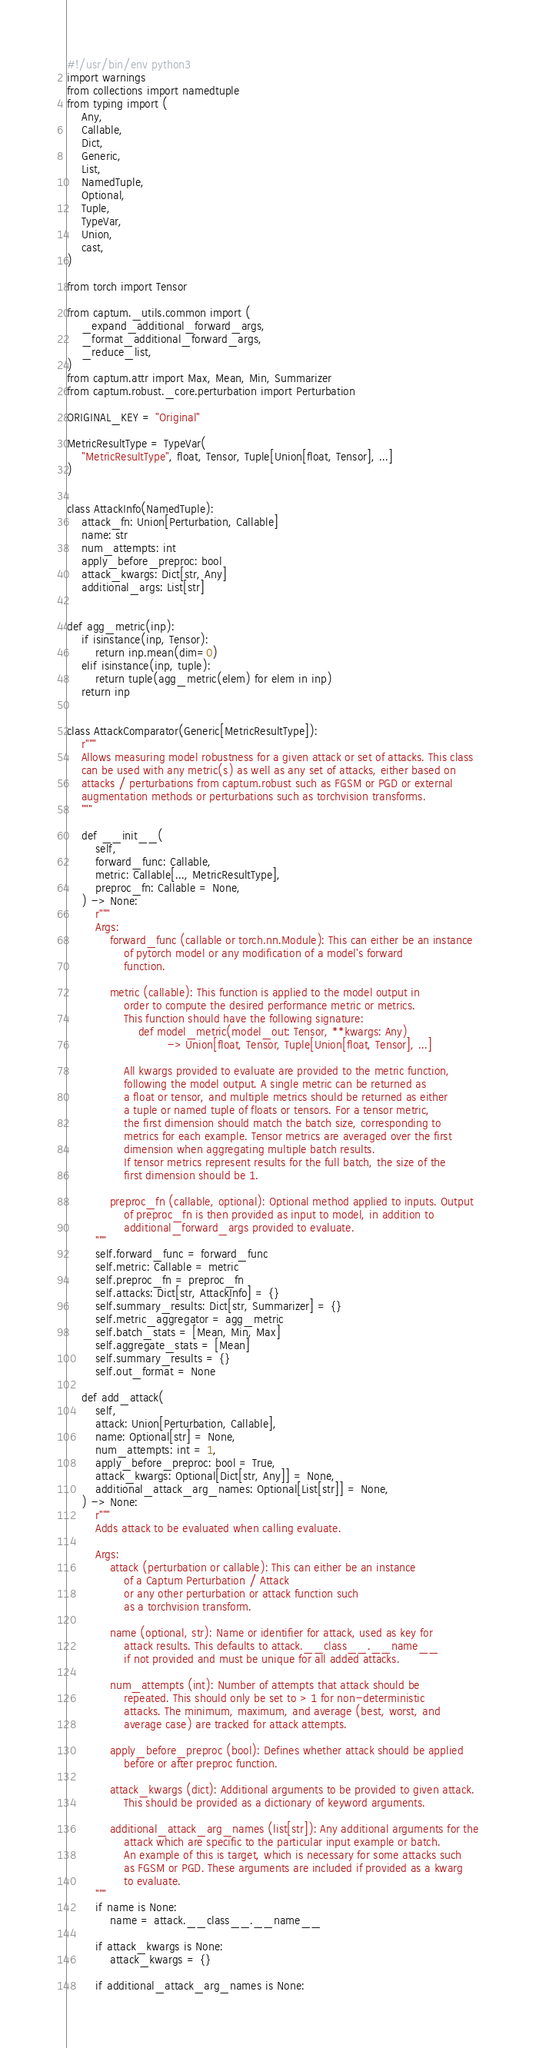<code> <loc_0><loc_0><loc_500><loc_500><_Python_>#!/usr/bin/env python3
import warnings
from collections import namedtuple
from typing import (
    Any,
    Callable,
    Dict,
    Generic,
    List,
    NamedTuple,
    Optional,
    Tuple,
    TypeVar,
    Union,
    cast,
)

from torch import Tensor

from captum._utils.common import (
    _expand_additional_forward_args,
    _format_additional_forward_args,
    _reduce_list,
)
from captum.attr import Max, Mean, Min, Summarizer
from captum.robust._core.perturbation import Perturbation

ORIGINAL_KEY = "Original"

MetricResultType = TypeVar(
    "MetricResultType", float, Tensor, Tuple[Union[float, Tensor], ...]
)


class AttackInfo(NamedTuple):
    attack_fn: Union[Perturbation, Callable]
    name: str
    num_attempts: int
    apply_before_preproc: bool
    attack_kwargs: Dict[str, Any]
    additional_args: List[str]


def agg_metric(inp):
    if isinstance(inp, Tensor):
        return inp.mean(dim=0)
    elif isinstance(inp, tuple):
        return tuple(agg_metric(elem) for elem in inp)
    return inp


class AttackComparator(Generic[MetricResultType]):
    r"""
    Allows measuring model robustness for a given attack or set of attacks. This class
    can be used with any metric(s) as well as any set of attacks, either based on
    attacks / perturbations from captum.robust such as FGSM or PGD or external
    augmentation methods or perturbations such as torchvision transforms.
    """

    def __init__(
        self,
        forward_func: Callable,
        metric: Callable[..., MetricResultType],
        preproc_fn: Callable = None,
    ) -> None:
        r"""
        Args:
            forward_func (callable or torch.nn.Module): This can either be an instance
                of pytorch model or any modification of a model's forward
                function.

            metric (callable): This function is applied to the model output in
                order to compute the desired performance metric or metrics.
                This function should have the following signature:
                    def model_metric(model_out: Tensor, **kwargs: Any)
                            -> Union[float, Tensor, Tuple[Union[float, Tensor], ...]

                All kwargs provided to evaluate are provided to the metric function,
                following the model output. A single metric can be returned as
                a float or tensor, and multiple metrics should be returned as either
                a tuple or named tuple of floats or tensors. For a tensor metric,
                the first dimension should match the batch size, corresponding to
                metrics for each example. Tensor metrics are averaged over the first
                dimension when aggregating multiple batch results.
                If tensor metrics represent results for the full batch, the size of the
                first dimension should be 1.

            preproc_fn (callable, optional): Optional method applied to inputs. Output
                of preproc_fn is then provided as input to model, in addition to
                additional_forward_args provided to evaluate.
        """
        self.forward_func = forward_func
        self.metric: Callable = metric
        self.preproc_fn = preproc_fn
        self.attacks: Dict[str, AttackInfo] = {}
        self.summary_results: Dict[str, Summarizer] = {}
        self.metric_aggregator = agg_metric
        self.batch_stats = [Mean, Min, Max]
        self.aggregate_stats = [Mean]
        self.summary_results = {}
        self.out_format = None

    def add_attack(
        self,
        attack: Union[Perturbation, Callable],
        name: Optional[str] = None,
        num_attempts: int = 1,
        apply_before_preproc: bool = True,
        attack_kwargs: Optional[Dict[str, Any]] = None,
        additional_attack_arg_names: Optional[List[str]] = None,
    ) -> None:
        r"""
        Adds attack to be evaluated when calling evaluate.

        Args:
            attack (perturbation or callable): This can either be an instance
                of a Captum Perturbation / Attack
                or any other perturbation or attack function such
                as a torchvision transform.

            name (optional, str): Name or identifier for attack, used as key for
                attack results. This defaults to attack.__class__.__name__
                if not provided and must be unique for all added attacks.

            num_attempts (int): Number of attempts that attack should be
                repeated. This should only be set to > 1 for non-deterministic
                attacks. The minimum, maximum, and average (best, worst, and
                average case) are tracked for attack attempts.

            apply_before_preproc (bool): Defines whether attack should be applied
                before or after preproc function.

            attack_kwargs (dict): Additional arguments to be provided to given attack.
                This should be provided as a dictionary of keyword arguments.

            additional_attack_arg_names (list[str]): Any additional arguments for the
                attack which are specific to the particular input example or batch.
                An example of this is target, which is necessary for some attacks such
                as FGSM or PGD. These arguments are included if provided as a kwarg
                to evaluate.
        """
        if name is None:
            name = attack.__class__.__name__

        if attack_kwargs is None:
            attack_kwargs = {}

        if additional_attack_arg_names is None:</code> 